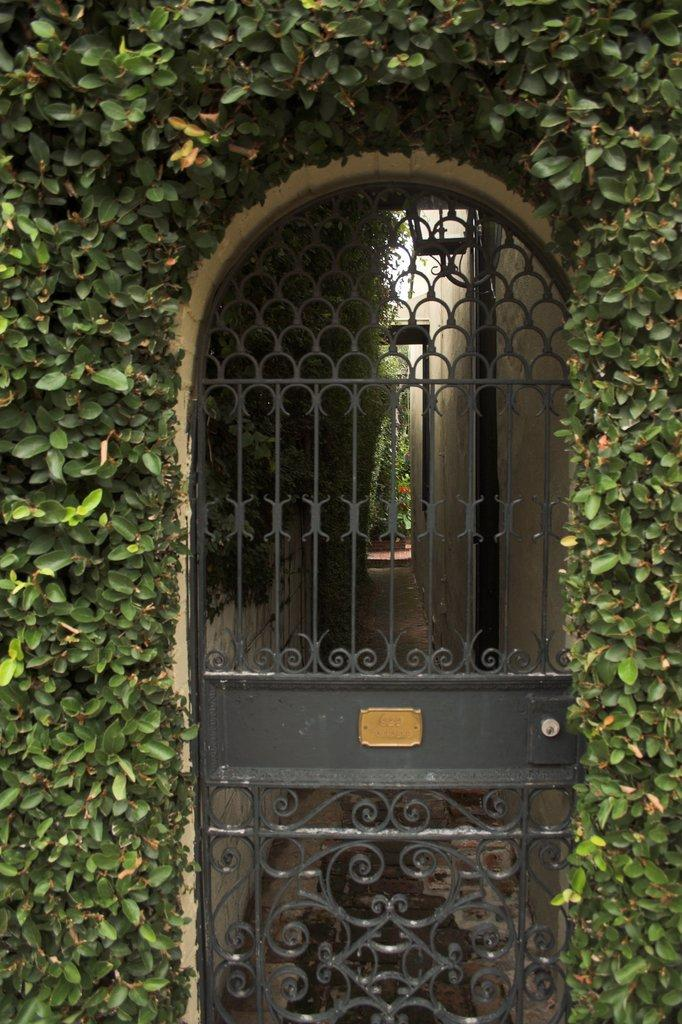What is the main object in the image? There is a fence gate in the image. What else can be seen in the image besides the fence gate? There are plants in the image. How much was the payment for the fence gate in the image? There is no information about payment in the image, as it only shows a fence gate and plants. 